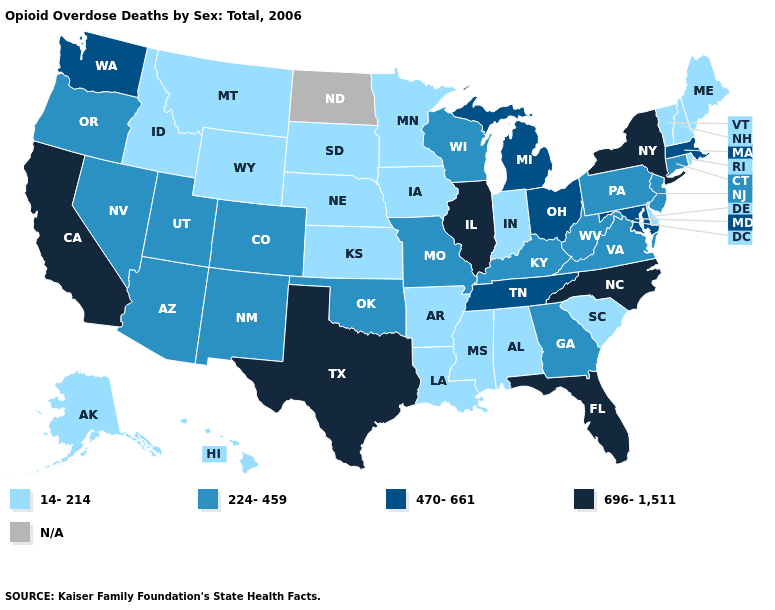Name the states that have a value in the range N/A?
Quick response, please. North Dakota. What is the lowest value in the South?
Concise answer only. 14-214. Name the states that have a value in the range 696-1,511?
Keep it brief. California, Florida, Illinois, New York, North Carolina, Texas. What is the value of Oklahoma?
Concise answer only. 224-459. Does Montana have the highest value in the West?
Be succinct. No. What is the value of Arkansas?
Write a very short answer. 14-214. Which states have the highest value in the USA?
Short answer required. California, Florida, Illinois, New York, North Carolina, Texas. What is the value of Washington?
Keep it brief. 470-661. Which states have the highest value in the USA?
Concise answer only. California, Florida, Illinois, New York, North Carolina, Texas. Among the states that border South Dakota , which have the lowest value?
Keep it brief. Iowa, Minnesota, Montana, Nebraska, Wyoming. What is the value of Rhode Island?
Keep it brief. 14-214. Name the states that have a value in the range 470-661?
Give a very brief answer. Maryland, Massachusetts, Michigan, Ohio, Tennessee, Washington. What is the lowest value in the MidWest?
Write a very short answer. 14-214. What is the value of Montana?
Answer briefly. 14-214. 